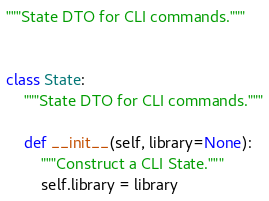Convert code to text. <code><loc_0><loc_0><loc_500><loc_500><_Python_>"""State DTO for CLI commands."""


class State:
    """State DTO for CLI commands."""

    def __init__(self, library=None):
        """Construct a CLI State."""
        self.library = library
</code> 